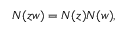Convert formula to latex. <formula><loc_0><loc_0><loc_500><loc_500>N ( z w ) = N ( z ) N ( w ) ,</formula> 